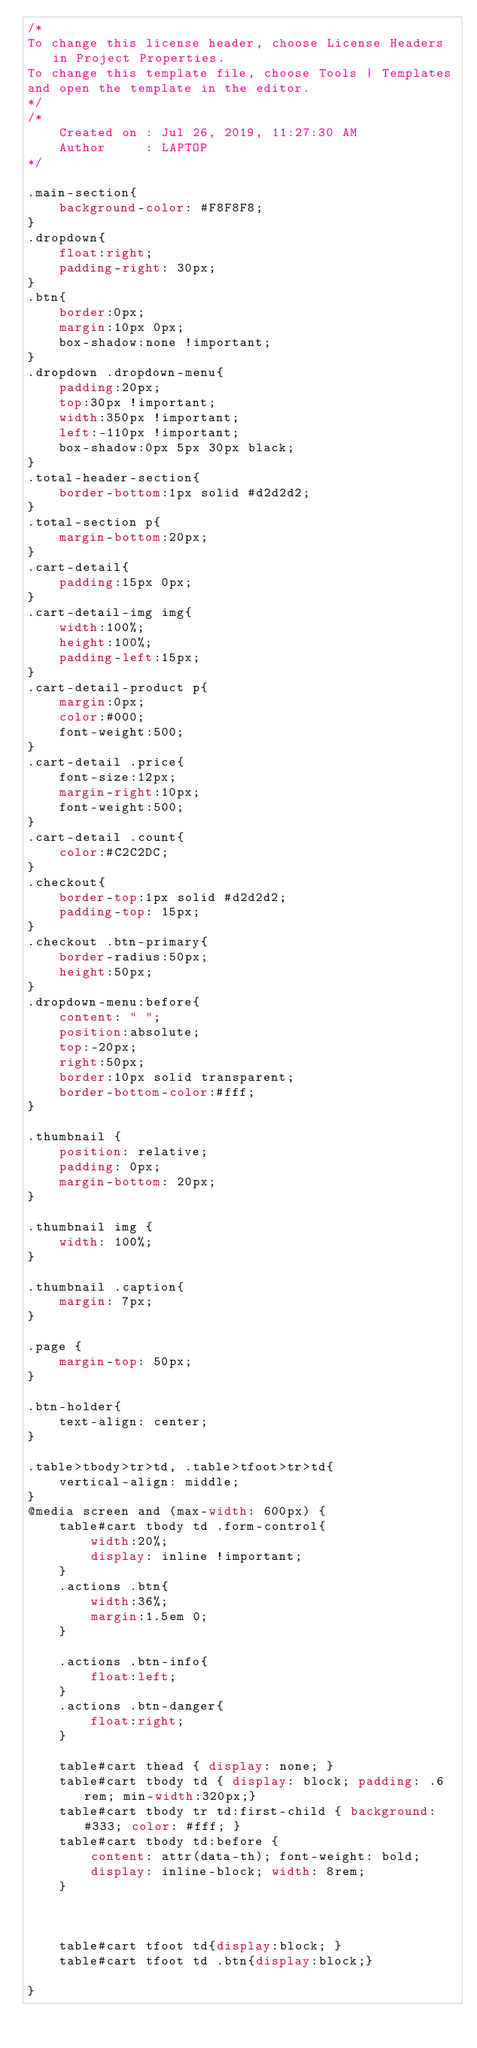Convert code to text. <code><loc_0><loc_0><loc_500><loc_500><_CSS_>/*
To change this license header, choose License Headers in Project Properties.
To change this template file, choose Tools | Templates
and open the template in the editor.
*/
/* 
    Created on : Jul 26, 2019, 11:27:30 AM
    Author     : LAPTOP
*/

.main-section{
    background-color: #F8F8F8;
}
.dropdown{
    float:right;
    padding-right: 30px;
}
.btn{
    border:0px;
    margin:10px 0px;
    box-shadow:none !important;
}
.dropdown .dropdown-menu{
    padding:20px;
    top:30px !important;
    width:350px !important;
    left:-110px !important;
    box-shadow:0px 5px 30px black;
}
.total-header-section{
    border-bottom:1px solid #d2d2d2;
}
.total-section p{
    margin-bottom:20px;
}
.cart-detail{
    padding:15px 0px;
}
.cart-detail-img img{
    width:100%;
    height:100%;
    padding-left:15px;
}
.cart-detail-product p{
    margin:0px;
    color:#000;
    font-weight:500;
}
.cart-detail .price{
    font-size:12px;
    margin-right:10px;
    font-weight:500;
}
.cart-detail .count{
    color:#C2C2DC;
}
.checkout{
    border-top:1px solid #d2d2d2;
    padding-top: 15px;
}
.checkout .btn-primary{
    border-radius:50px;
    height:50px;
}
.dropdown-menu:before{
    content: " ";
    position:absolute;
    top:-20px;
    right:50px;
    border:10px solid transparent;
    border-bottom-color:#fff;
}

.thumbnail {
    position: relative;
    padding: 0px;
    margin-bottom: 20px;
}

.thumbnail img {
    width: 100%;
}

.thumbnail .caption{
    margin: 7px;
}

.page {
    margin-top: 50px;
}

.btn-holder{
    text-align: center;
}

.table>tbody>tr>td, .table>tfoot>tr>td{
    vertical-align: middle;
}
@media screen and (max-width: 600px) {
    table#cart tbody td .form-control{
        width:20%;
        display: inline !important;
    }
    .actions .btn{
        width:36%;
        margin:1.5em 0;
    }

    .actions .btn-info{
        float:left;
    }
    .actions .btn-danger{
        float:right;
    }

    table#cart thead { display: none; }
    table#cart tbody td { display: block; padding: .6rem; min-width:320px;}
    table#cart tbody tr td:first-child { background: #333; color: #fff; }
    table#cart tbody td:before {
        content: attr(data-th); font-weight: bold;
        display: inline-block; width: 8rem;
    }



    table#cart tfoot td{display:block; }
    table#cart tfoot td .btn{display:block;}

}</code> 